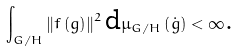<formula> <loc_0><loc_0><loc_500><loc_500>\int _ { G / H } \left \| f \left ( g \right ) \right \| ^ { 2 } \text {d} \mu _ { G / H } \left ( \dot { g } \right ) < \infty \text {.}</formula> 